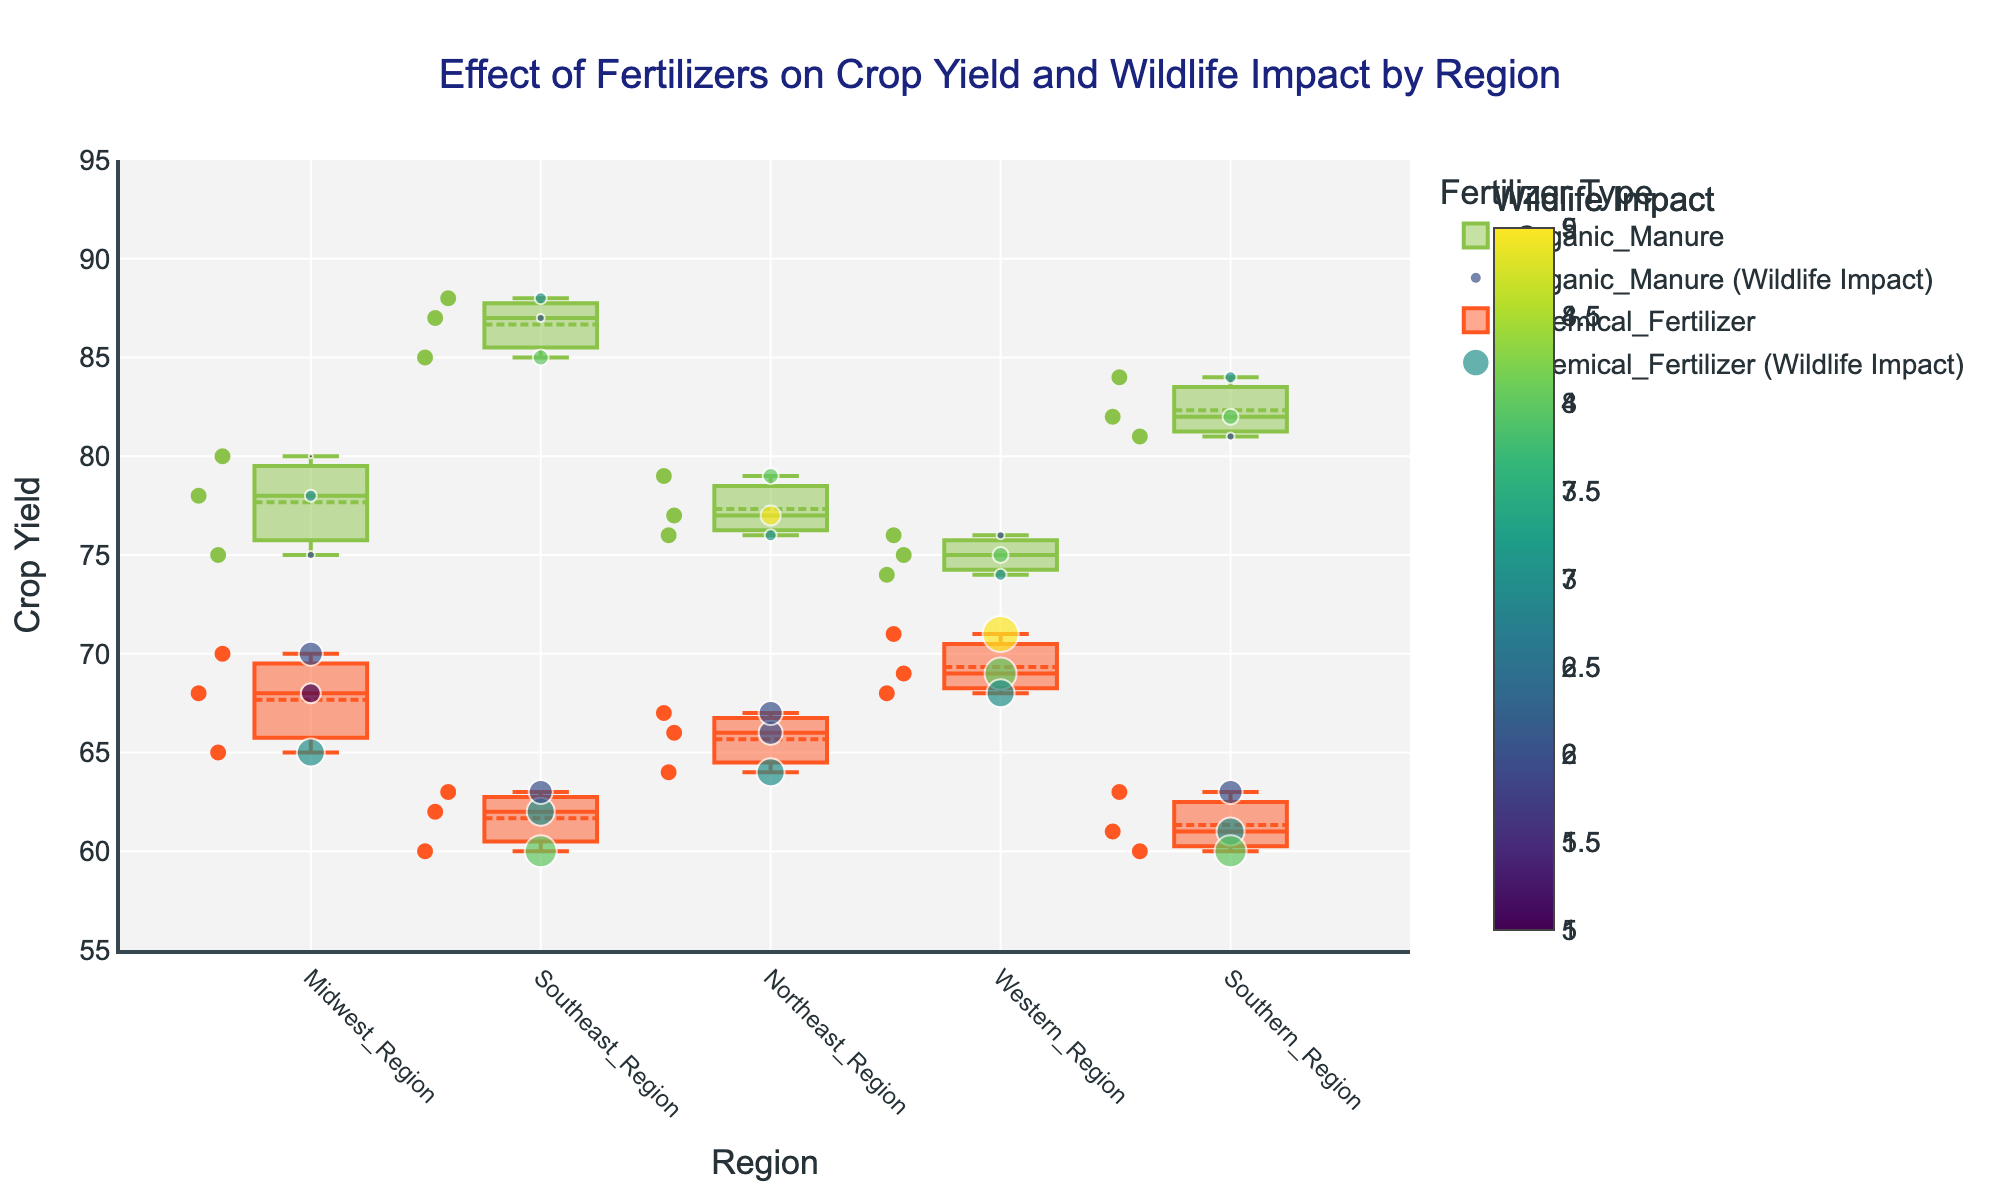How does the median crop yield compare between Organic Manure and Chemical Fertilizer in the Midwest Region? The box plot visually presents the median crop yields for both Organic Manure and Chemical Fertilizer in the Midwest Region. The median for Organic Manure appears higher than that for Chemical Fertilizer.
Answer: Organic Manure has a higher median What is the range of wildlife impact scores for Organic Manure in the Southeast Region? The range of wildlife impact scores is determined by the difference between the highest and lowest values observed. For Organic Manure in the Southeast Region, the values are 4, 3, and 2, giving a range of 4 - 2 = 2
Answer: 2 Which fertilizer type corresponds with higher wildlife impact on average in the Southern Region? By examining the scatter points' color and legend, we can see that Chemical Fertilizer has scatter markers with higher average wildlife impact scores compared to Organic Manure in the Southern Region.
Answer: Chemical Fertilizer Are there any outliers for crop yield in the Western Region? If so, which fertilizer type do they correspond to? The box plot can detect outliers. Outliers are usually marked separately. No outliers are marked in the Western Region for either fertilizer type.
Answer: No Which region shows the highest crop yield using Organic Manure? By comparing the positions of the boxes for Organic Manure across Regions, we can observe that the Southeast Region has the highest median crop yield.
Answer: Southeast Region How does the crop yield variability (IQR) compare between Organic Manure in the Midwest Region and Chemical Fertilizer in the Northeast Region? Interquartile Range (IQR) is the distance between the upper and lower quartiles. Organic Manure in the Midwest has a wider IQR than Chemical Fertilizer in the Northeast, indicating higher variability.
Answer: Midwest has higher variability What general trend can be observed regarding the wildlife impact for regions using Chemical Fertilizer? By observing the scatter points' colors associated with Chemical Fertilizer across regions, we see that they generally show higher wildlife impact scores (darker colors) compared to the scatter points for Organic Manure.
Answer: Higher wildlife impact What is the difference in average crop yield between the Northeast and Western Regions using Organic Manure? The average can be estimated by observing the central tendency of the box plot for Organic Manure in both regions. Organic Manure appears to produce slightly higher yields in the Northeast over the Western Region.
Answer: Northeast is higher Is there a correlation between increased wildlife impact and decreased crop yield for any fertilizer types across regions? Correlation is inferred by jointly examining the trend of scatter point sizes/colors (wildlife impact) and crop yield positions. Both show that for Chemical Fertilizer, higher wildlife impact is associated with lower crop yields.
Answer: Yes 